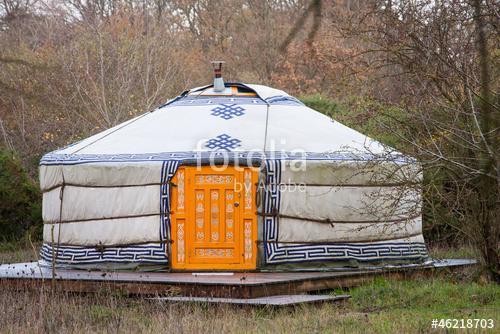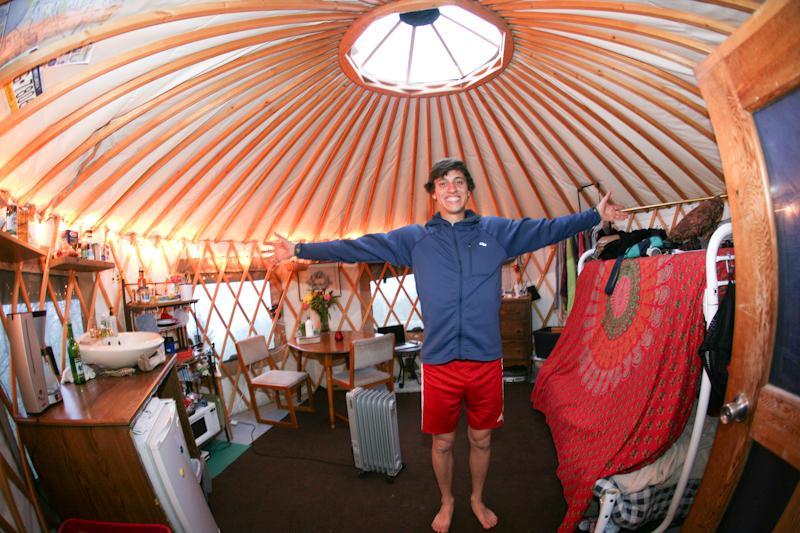The first image is the image on the left, the second image is the image on the right. For the images shown, is this caption "The right image contains at least one human being." true? Answer yes or no. Yes. The first image is the image on the left, the second image is the image on the right. Evaluate the accuracy of this statement regarding the images: "One image shows the interior of a yurt with at least two support beams and latticed walls, with a light fixture hanging from the center of the ceiling.". Is it true? Answer yes or no. No. 